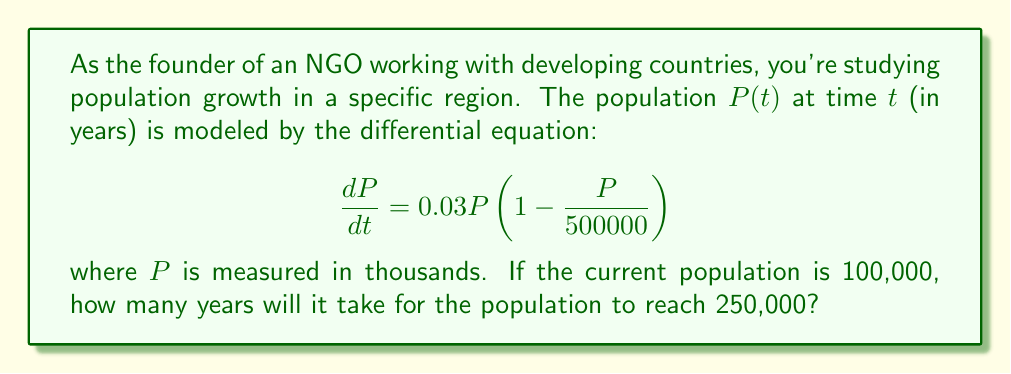Solve this math problem. To solve this problem, we need to use the method of separation of variables and integration:

1) First, let's separate the variables:

   $$\frac{dP}{P(1 - \frac{P}{500000})} = 0.03dt$$

2) Integrate both sides:

   $$\int \frac{dP}{P(1 - \frac{P}{500000})} = \int 0.03dt$$

3) The left side can be integrated using partial fractions:

   $$\int \frac{dP}{P(1 - \frac{P}{500000})} = -\frac{500000}{P} - \ln|500000 - P| + C_1$$

4) The right side integrates to:

   $$\int 0.03dt = 0.03t + C_2$$

5) Combining these and solving for $t$:

   $$-\frac{500000}{P} - \ln|500000 - P| = 0.03t + C$$

   where $C = C_2 - C_1$

6) Now, we can use the initial condition $P(0) = 100$ (remember, $P$ is in thousands) to find $C$:

   $$-\frac{500000}{100000} - \ln|500000 - 100000| = C$$
   $$-5 - \ln(400000) = C$$

7) We want to find $t$ when $P = 250$ (thousand). Substituting this and our value for $C$:

   $$-\frac{500000}{250000} - \ln|500000 - 250000| = 0.03t + (-5 - \ln(400000))$$

8) Simplify and solve for $t$:

   $$-2 - \ln(250000) = 0.03t - 5 - \ln(400000)$$
   $$3 + \ln(\frac{400000}{250000}) = 0.03t$$
   $$3 + \ln(1.6) = 0.03t$$
   $$3 + 0.47 = 0.03t$$
   $$3.47 = 0.03t$$

9) Finally:

   $$t = \frac{3.47}{0.03} \approx 115.67$$
Answer: It will take approximately 115.67 years for the population to reach 250,000. 